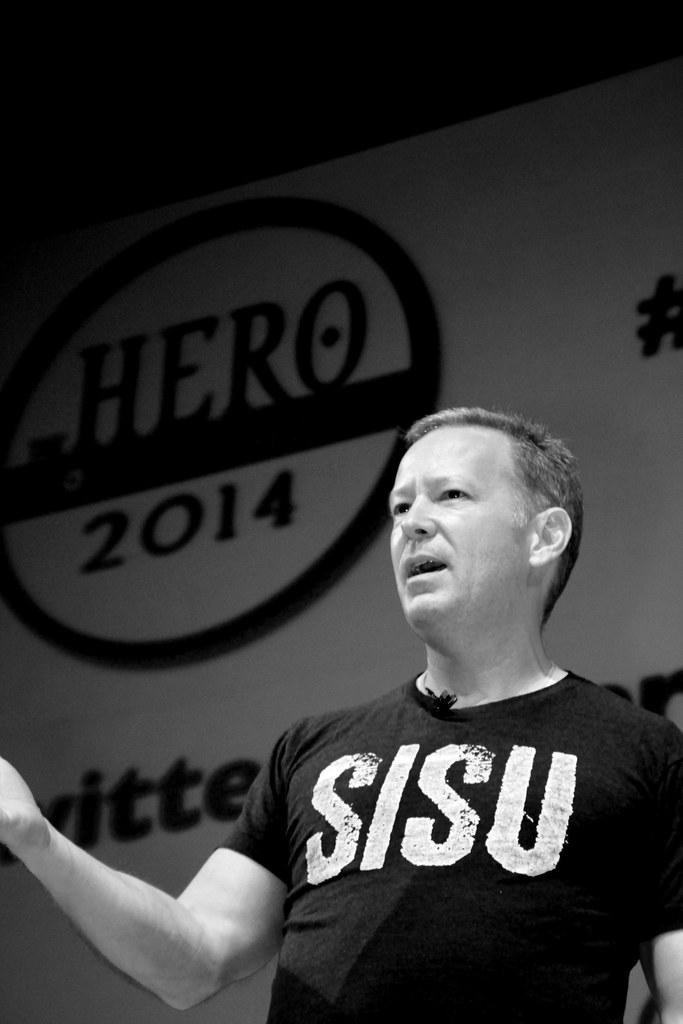<image>
Give a short and clear explanation of the subsequent image. A man with a shirt that says Sisu is speaking in front of a sign that says Hero 2014. 